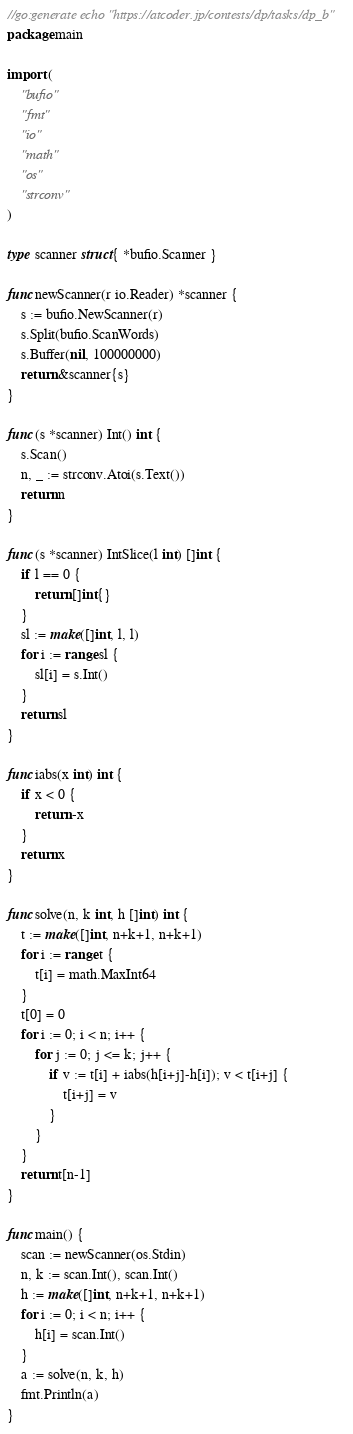Convert code to text. <code><loc_0><loc_0><loc_500><loc_500><_Go_>//go:generate echo "https://atcoder.jp/contests/dp/tasks/dp_b"
package main

import (
	"bufio"
	"fmt"
	"io"
	"math"
	"os"
	"strconv"
)

type scanner struct{ *bufio.Scanner }

func newScanner(r io.Reader) *scanner {
	s := bufio.NewScanner(r)
	s.Split(bufio.ScanWords)
	s.Buffer(nil, 100000000)
	return &scanner{s}
}

func (s *scanner) Int() int {
	s.Scan()
	n, _ := strconv.Atoi(s.Text())
	return n
}

func (s *scanner) IntSlice(l int) []int {
	if l == 0 {
		return []int{}
	}
	sl := make([]int, l, l)
	for i := range sl {
		sl[i] = s.Int()
	}
	return sl
}

func iabs(x int) int {
	if x < 0 {
		return -x
	}
	return x
}

func solve(n, k int, h []int) int {
	t := make([]int, n+k+1, n+k+1)
	for i := range t {
		t[i] = math.MaxInt64
	}
	t[0] = 0
	for i := 0; i < n; i++ {
		for j := 0; j <= k; j++ {
			if v := t[i] + iabs(h[i+j]-h[i]); v < t[i+j] {
				t[i+j] = v
			}
		}
	}
	return t[n-1]
}

func main() {
	scan := newScanner(os.Stdin)
	n, k := scan.Int(), scan.Int()
	h := make([]int, n+k+1, n+k+1)
	for i := 0; i < n; i++ {
		h[i] = scan.Int()
	}
	a := solve(n, k, h)
	fmt.Println(a)
}
</code> 